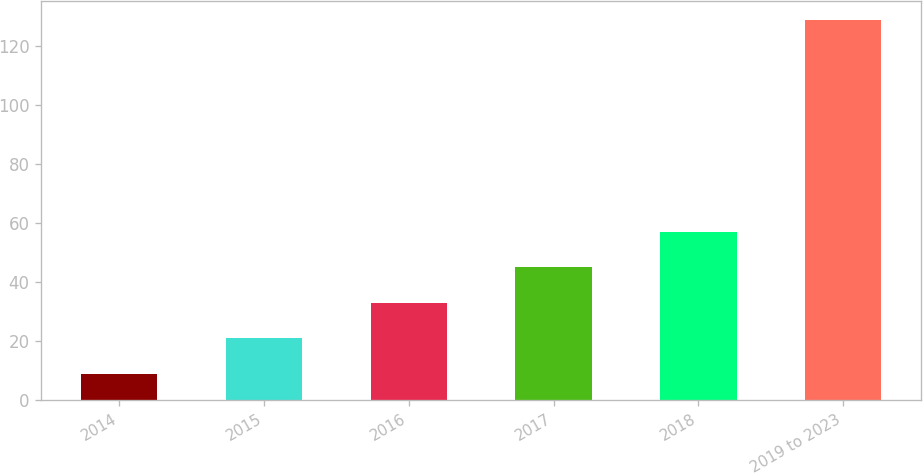<chart> <loc_0><loc_0><loc_500><loc_500><bar_chart><fcel>2014<fcel>2015<fcel>2016<fcel>2017<fcel>2018<fcel>2019 to 2023<nl><fcel>9<fcel>21<fcel>33<fcel>45<fcel>57<fcel>129<nl></chart> 